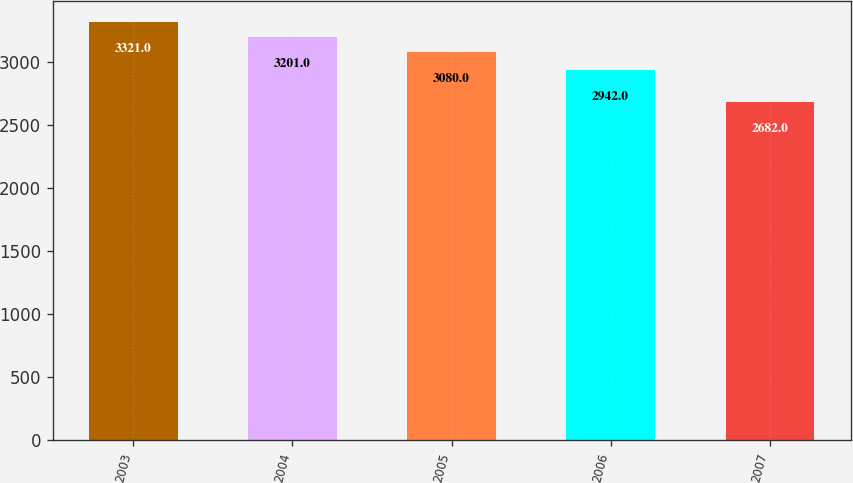Convert chart. <chart><loc_0><loc_0><loc_500><loc_500><bar_chart><fcel>2003<fcel>2004<fcel>2005<fcel>2006<fcel>2007<nl><fcel>3321<fcel>3201<fcel>3080<fcel>2942<fcel>2682<nl></chart> 